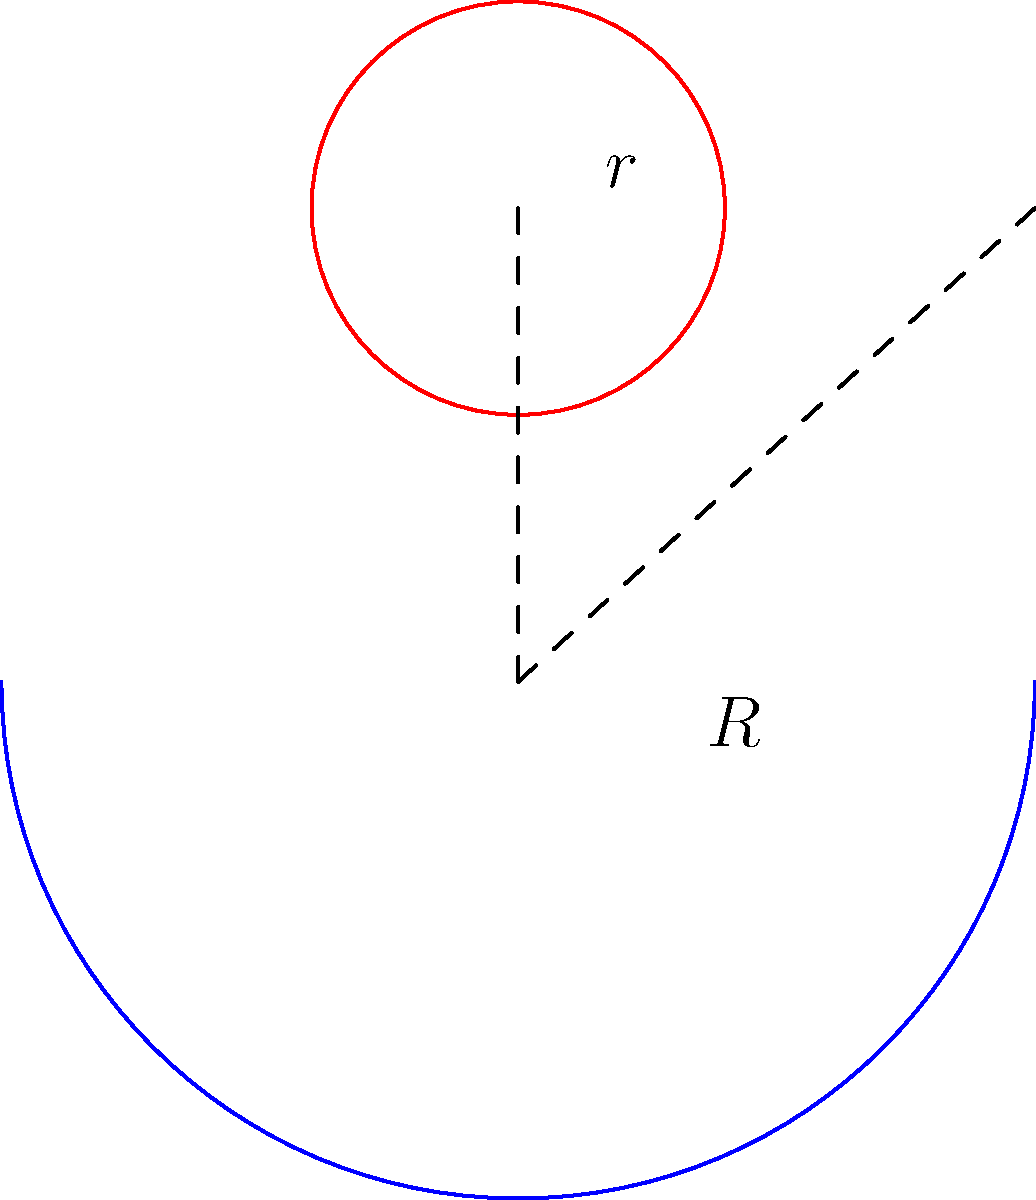On a negatively curved surface with constant curvature (represented by a sphere of radius $R$), you need to calculate the optimal size for a circular subwoofer. If the subwoofer has a radius $r$ on the curved surface, and the area of the circle on this surface is given by $A = 2\pi R^2(1-\cos(\frac{r}{R}))$, determine the radius $r$ that gives an area of $50\text{ cm}^2$ when $R = 10\text{ cm}$. Round your answer to the nearest millimeter. To solve this problem, we'll follow these steps:

1) We are given the formula for the area of a circle on a negatively curved surface:
   $A = 2\pi R^2(1-\cos(\frac{r}{R}))$

2) We know the following:
   $A = 50\text{ cm}^2$
   $R = 10\text{ cm}$

3) Let's substitute these values into the formula:
   $50 = 2\pi (10)^2(1-\cos(\frac{r}{10}))$

4) Simplify:
   $50 = 200\pi(1-\cos(\frac{r}{10}))$

5) Divide both sides by $200\pi$:
   $\frac{50}{200\pi} = 1-\cos(\frac{r}{10})$

6) Subtract both sides from 1:
   $1 - \frac{50}{200\pi} = \cos(\frac{r}{10})$

7) Take the inverse cosine (arccos) of both sides:
   $\arccos(1 - \frac{50}{200\pi}) = \frac{r}{10}$

8) Multiply both sides by 10:
   $10 \arccos(1 - \frac{50}{200\pi}) = r$

9) Calculate the value (using a calculator):
   $r \approx 3.952\text{ cm}$

10) Rounding to the nearest millimeter:
    $r \approx 4.0\text{ cm}$
Answer: $4.0\text{ cm}$ 